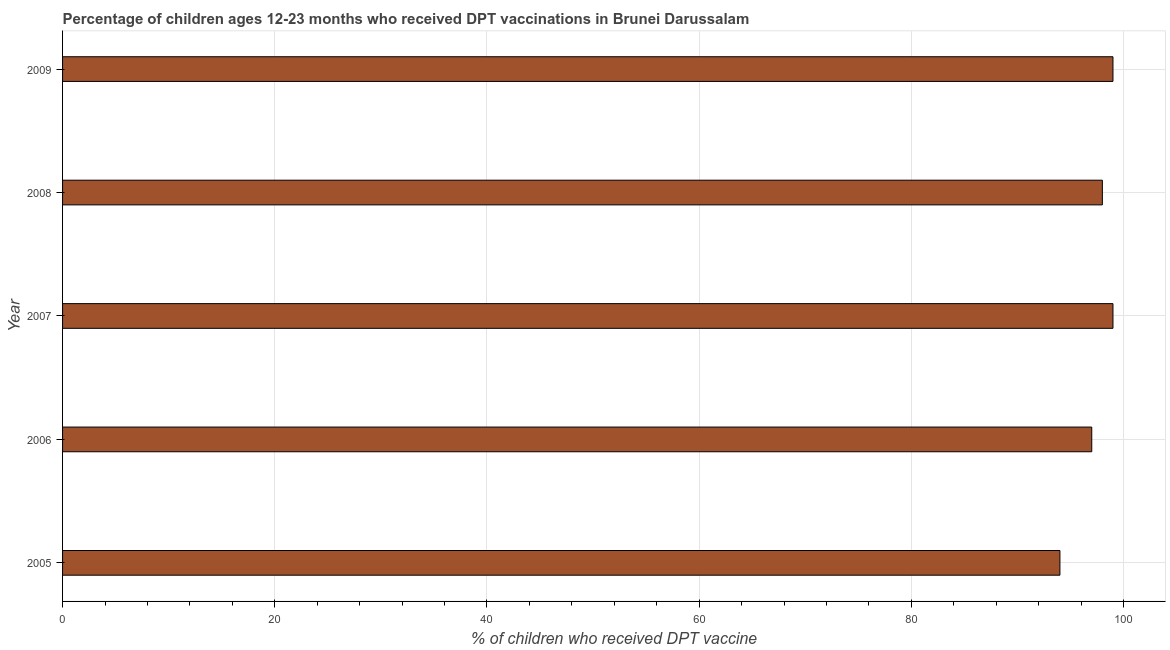Does the graph contain any zero values?
Keep it short and to the point. No. Does the graph contain grids?
Give a very brief answer. Yes. What is the title of the graph?
Provide a short and direct response. Percentage of children ages 12-23 months who received DPT vaccinations in Brunei Darussalam. What is the label or title of the X-axis?
Provide a short and direct response. % of children who received DPT vaccine. What is the label or title of the Y-axis?
Offer a terse response. Year. Across all years, what is the maximum percentage of children who received dpt vaccine?
Your answer should be very brief. 99. Across all years, what is the minimum percentage of children who received dpt vaccine?
Give a very brief answer. 94. In which year was the percentage of children who received dpt vaccine minimum?
Your response must be concise. 2005. What is the sum of the percentage of children who received dpt vaccine?
Your answer should be very brief. 487. What is the average percentage of children who received dpt vaccine per year?
Your answer should be very brief. 97. In how many years, is the percentage of children who received dpt vaccine greater than 24 %?
Your answer should be compact. 5. Is the difference between the percentage of children who received dpt vaccine in 2006 and 2009 greater than the difference between any two years?
Offer a terse response. No. What is the difference between the highest and the lowest percentage of children who received dpt vaccine?
Your answer should be compact. 5. In how many years, is the percentage of children who received dpt vaccine greater than the average percentage of children who received dpt vaccine taken over all years?
Your answer should be compact. 3. How many bars are there?
Your answer should be compact. 5. How many years are there in the graph?
Give a very brief answer. 5. What is the difference between two consecutive major ticks on the X-axis?
Keep it short and to the point. 20. What is the % of children who received DPT vaccine of 2005?
Ensure brevity in your answer.  94. What is the % of children who received DPT vaccine in 2006?
Your answer should be compact. 97. What is the % of children who received DPT vaccine in 2009?
Your answer should be very brief. 99. What is the difference between the % of children who received DPT vaccine in 2005 and 2007?
Ensure brevity in your answer.  -5. What is the difference between the % of children who received DPT vaccine in 2005 and 2008?
Make the answer very short. -4. What is the difference between the % of children who received DPT vaccine in 2005 and 2009?
Ensure brevity in your answer.  -5. What is the difference between the % of children who received DPT vaccine in 2006 and 2007?
Keep it short and to the point. -2. What is the difference between the % of children who received DPT vaccine in 2006 and 2008?
Offer a terse response. -1. What is the difference between the % of children who received DPT vaccine in 2006 and 2009?
Give a very brief answer. -2. What is the difference between the % of children who received DPT vaccine in 2007 and 2009?
Your response must be concise. 0. What is the ratio of the % of children who received DPT vaccine in 2005 to that in 2006?
Your answer should be very brief. 0.97. What is the ratio of the % of children who received DPT vaccine in 2005 to that in 2007?
Your response must be concise. 0.95. What is the ratio of the % of children who received DPT vaccine in 2005 to that in 2008?
Ensure brevity in your answer.  0.96. What is the ratio of the % of children who received DPT vaccine in 2005 to that in 2009?
Offer a very short reply. 0.95. What is the ratio of the % of children who received DPT vaccine in 2006 to that in 2009?
Keep it short and to the point. 0.98. What is the ratio of the % of children who received DPT vaccine in 2007 to that in 2008?
Your response must be concise. 1.01. What is the ratio of the % of children who received DPT vaccine in 2008 to that in 2009?
Provide a short and direct response. 0.99. 